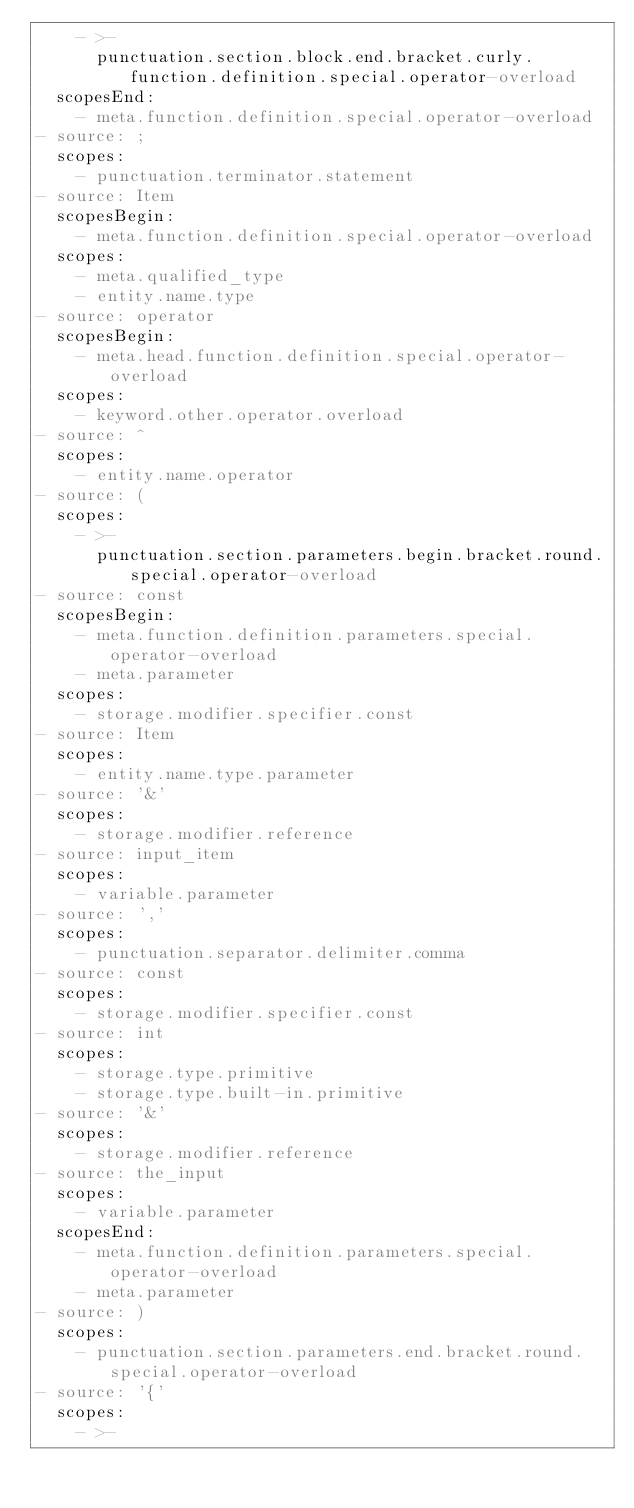<code> <loc_0><loc_0><loc_500><loc_500><_YAML_>    - >-
      punctuation.section.block.end.bracket.curly.function.definition.special.operator-overload
  scopesEnd:
    - meta.function.definition.special.operator-overload
- source: ;
  scopes:
    - punctuation.terminator.statement
- source: Item
  scopesBegin:
    - meta.function.definition.special.operator-overload
  scopes:
    - meta.qualified_type
    - entity.name.type
- source: operator
  scopesBegin:
    - meta.head.function.definition.special.operator-overload
  scopes:
    - keyword.other.operator.overload
- source: ^
  scopes:
    - entity.name.operator
- source: (
  scopes:
    - >-
      punctuation.section.parameters.begin.bracket.round.special.operator-overload
- source: const
  scopesBegin:
    - meta.function.definition.parameters.special.operator-overload
    - meta.parameter
  scopes:
    - storage.modifier.specifier.const
- source: Item
  scopes:
    - entity.name.type.parameter
- source: '&'
  scopes:
    - storage.modifier.reference
- source: input_item
  scopes:
    - variable.parameter
- source: ','
  scopes:
    - punctuation.separator.delimiter.comma
- source: const
  scopes:
    - storage.modifier.specifier.const
- source: int
  scopes:
    - storage.type.primitive
    - storage.type.built-in.primitive
- source: '&'
  scopes:
    - storage.modifier.reference
- source: the_input
  scopes:
    - variable.parameter
  scopesEnd:
    - meta.function.definition.parameters.special.operator-overload
    - meta.parameter
- source: )
  scopes:
    - punctuation.section.parameters.end.bracket.round.special.operator-overload
- source: '{'
  scopes:
    - >-</code> 